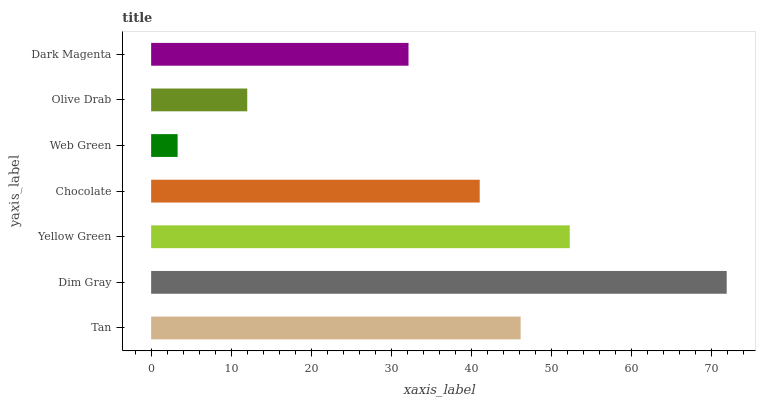Is Web Green the minimum?
Answer yes or no. Yes. Is Dim Gray the maximum?
Answer yes or no. Yes. Is Yellow Green the minimum?
Answer yes or no. No. Is Yellow Green the maximum?
Answer yes or no. No. Is Dim Gray greater than Yellow Green?
Answer yes or no. Yes. Is Yellow Green less than Dim Gray?
Answer yes or no. Yes. Is Yellow Green greater than Dim Gray?
Answer yes or no. No. Is Dim Gray less than Yellow Green?
Answer yes or no. No. Is Chocolate the high median?
Answer yes or no. Yes. Is Chocolate the low median?
Answer yes or no. Yes. Is Dark Magenta the high median?
Answer yes or no. No. Is Tan the low median?
Answer yes or no. No. 